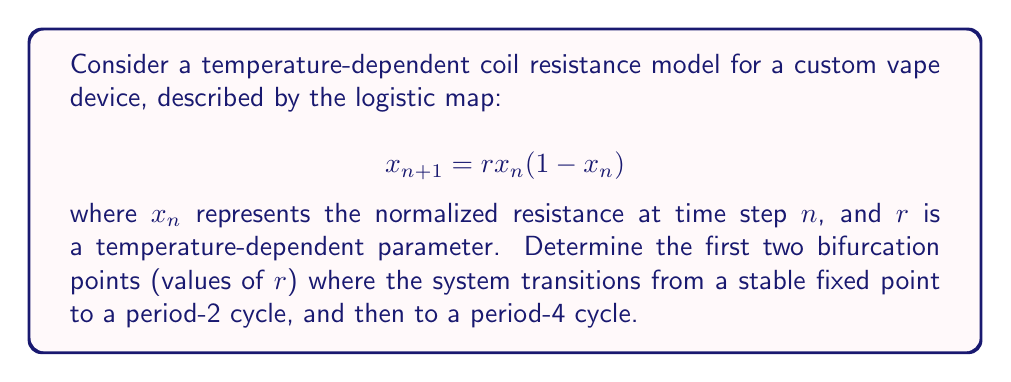Give your solution to this math problem. 1. For the logistic map, the first bifurcation occurs when the system transitions from a stable fixed point to a period-2 cycle. This happens when the derivative of the map at the fixed point equals -1.

2. The fixed point of the map is given by:
   $$x^* = 1 - \frac{1}{r}$$

3. The derivative of the map is:
   $$\frac{dx_{n+1}}{dx_n} = r(1-2x_n)$$

4. At the fixed point, the derivative is:
   $$\frac{dx_{n+1}}{dx_n}\bigg|_{x^*} = r(1-2(1-\frac{1}{r})) = 2-r$$

5. Setting this equal to -1 for the first bifurcation:
   $$2-r = -1$$
   $$r = 3$$

6. The second bifurcation, from period-2 to period-4, occurs at:
   $$r = 1 + \sqrt{6} \approx 3.449489742783178$$

This value is derived from more complex analysis of the period-doubling cascade in the logistic map.
Answer: $r_1 = 3$, $r_2 \approx 3.449489742783178$ 